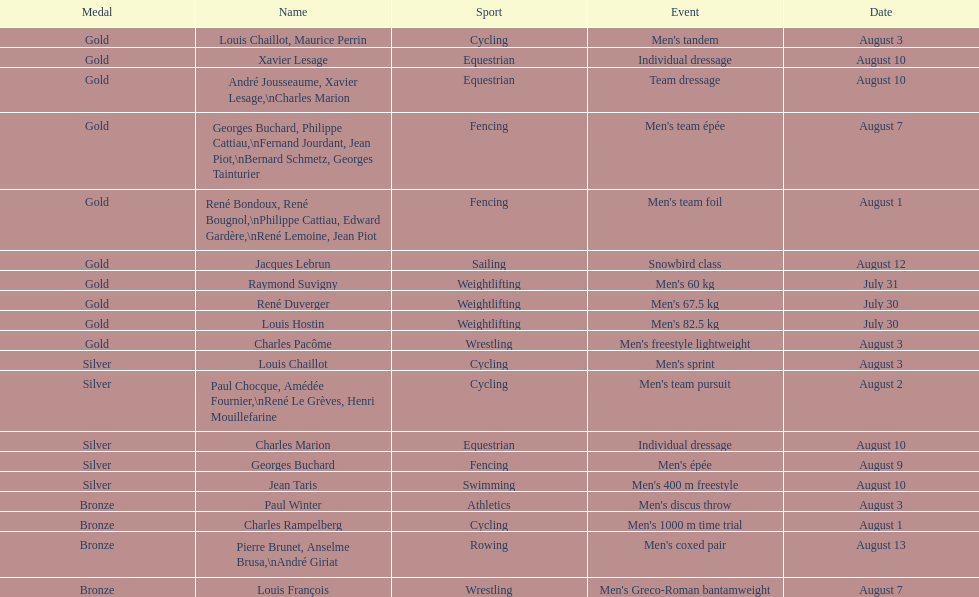Which sport is mentioned initially? Cycling. 